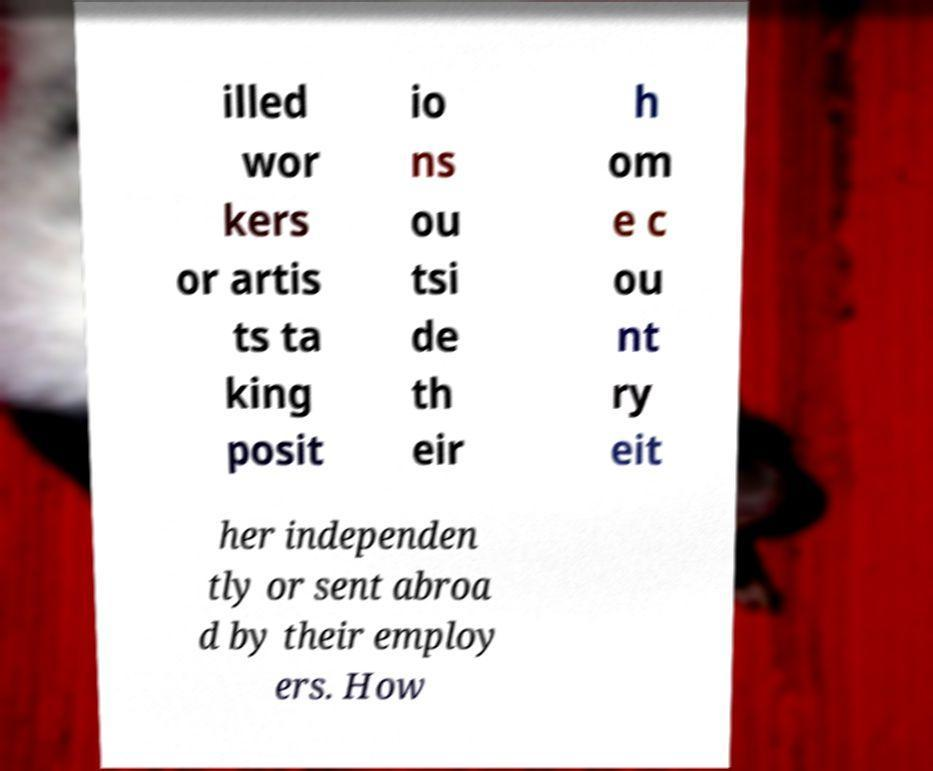Could you assist in decoding the text presented in this image and type it out clearly? illed wor kers or artis ts ta king posit io ns ou tsi de th eir h om e c ou nt ry eit her independen tly or sent abroa d by their employ ers. How 